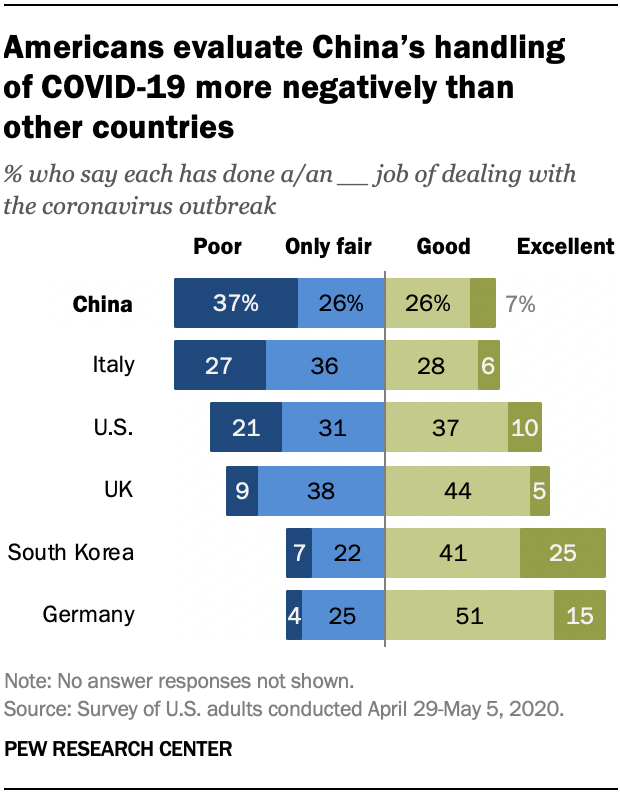Indicate a few pertinent items in this graphic. According to a recent survey, 37% of Americans believe that China has done a poor job in dealing with the COVID-19 outbreak. In the light blue bar, are there any values that are greater than 30? 